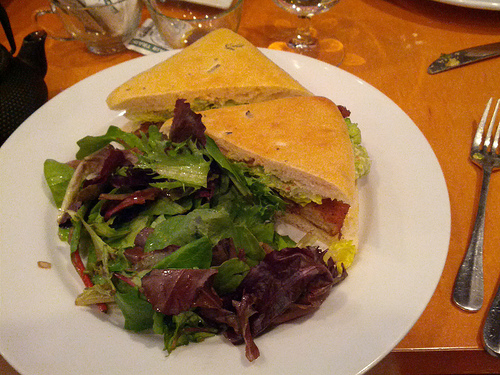Could this meal be considered healthy? Provide reasons based on the visible ingredients. Generally, this meal could be considered balanced. It includes protein from the ham, dairy from the cheese, fiber and vitamins from the lettuce and tomatoes, plus the mixed greens in the salad add additional nutritional value. However, moderation in portion size and dressing choice can further influence its healthiness. 